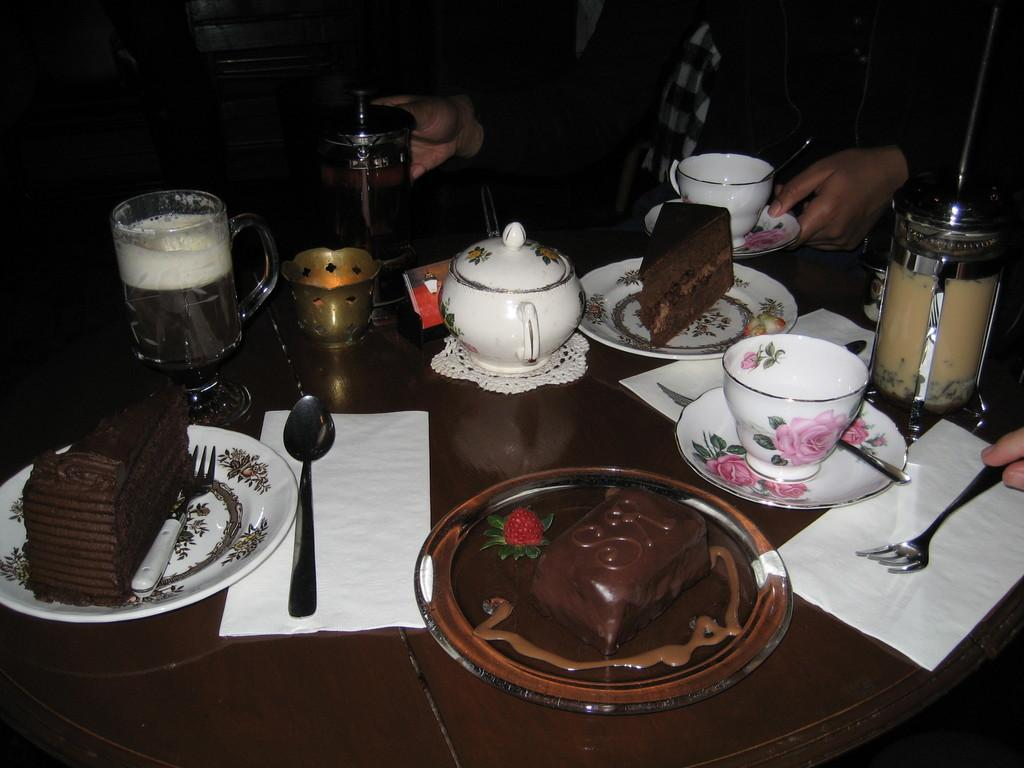What is the main object in the image? There is a teapot in the image. What other objects are present in the image? There is a plate, chocolate, a fork, a napkin, a saucer, and cake in the image. How many forks are visible in the image? There are two forks in the image. What might be used for cleaning or wiping in the image? A napkin is present in the image for cleaning or wiping. What is the background of the image? In the background, there is a person in the image. What type of engine is visible in the image? There is no engine present in the image. Can you describe the zipper on the cake in the image? There is no zipper on the cake in the image; it is a dessert and not a garment. 